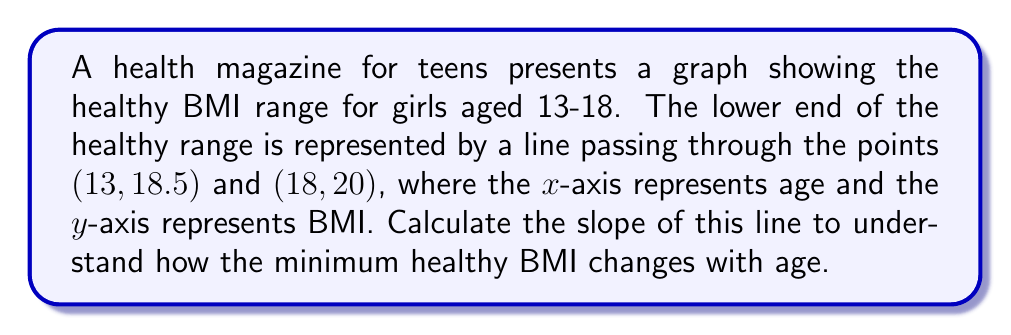Solve this math problem. To calculate the slope of the line, we'll use the slope formula:

$$ m = \frac{y_2 - y_1}{x_2 - x_1} $$

Where $(x_1, y_1)$ is the first point and $(x_2, y_2)$ is the second point.

Given:
- Point 1: (13, 18.5)
- Point 2: (18, 20)

Let's substitute these values into the formula:

$$ m = \frac{20 - 18.5}{18 - 13} = \frac{1.5}{5} $$

Simplifying:

$$ m = 0.3 $$

This slope indicates that for every year increase in age (x-axis), the minimum healthy BMI (y-axis) increases by 0.3 units.

It's important to note that this linear representation is a simplification. In reality, healthy BMI ranges are more complex and can vary based on individual factors. This graph should not be used as a sole indicator of health or body image.
Answer: $m = 0.3$ 